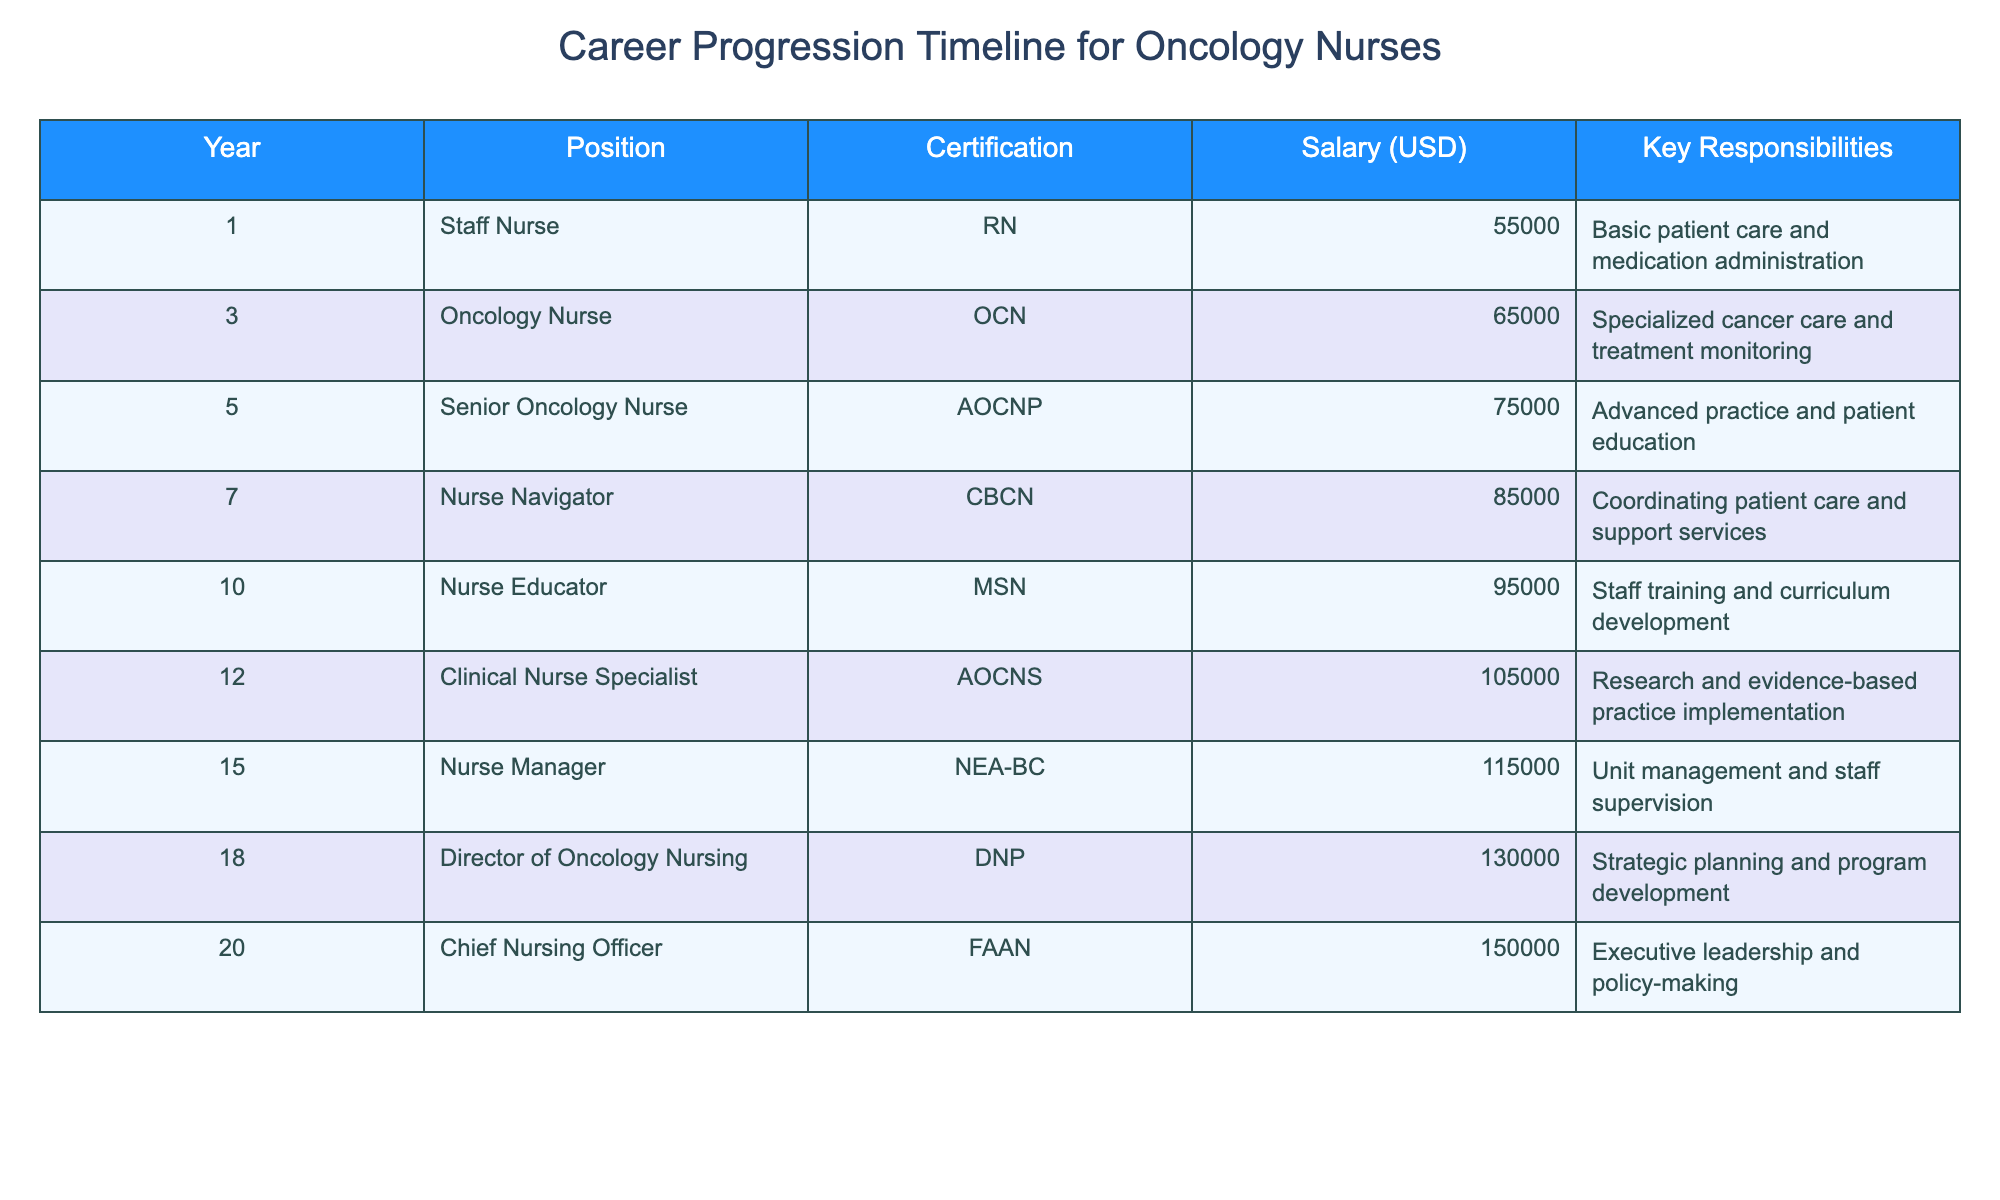What is the salary of a Nurse Navigator? The table lists the salary of a Nurse Navigator as 85,000 USD in year 7.
Answer: 85,000 USD How many years does it take to become a Chief Nursing Officer from a Staff Nurse? The table shows that it takes 20 years to progress from a Staff Nurse to a Chief Nursing Officer (Year 1 to Year 20).
Answer: 20 years What certification is required for a Nurse Educator? According to the table, the required certification for a Nurse Educator is MSN.
Answer: MSN What is the average salary of oncology nurses over the first 10 years? To find the average, add the salaries from years 1 to 10: 55,000 + 65,000 + 75,000 + 85,000 + 95,000 + 105,000 + 115,000 + 130,000 = 725,000, then divide by 8, which gives an average of 90,625 USD.
Answer: 90,625 USD Is the salary of a Clinical Nurse Specialist greater than that of a Nurse Navigator? The table shows that the salary of a Clinical Nurse Specialist is 105,000 USD and that of a Nurse Navigator is 85,000 USD, so yes, it is greater.
Answer: Yes What are the key responsibilities of a Senior Oncology Nurse? The table lists the responsibilities of a Senior Oncology Nurse as advanced practice and patient education.
Answer: Advanced practice and patient education How many positions are considered management roles in the table? The positions that can be classified as management roles are Nurse Manager, Director of Oncology Nursing, and Chief Nursing Officer, making a total of 3 management roles.
Answer: 3 positions What is the difference in salary between a Nurse Educator and a Nurse Manager? The salary of a Nurse Educator is 95,000 USD, and the salary of a Nurse Manager is 115,000 USD. The difference is 115,000 - 95,000 = 20,000 USD.
Answer: 20,000 USD In how many years does the salary exceed 100,000 USD? From years 12 to 20, the salaries are 105,000, 115,000, 130,000, and 150,000 USD, which counts as 8 years in total.
Answer: 8 years Which position has the highest salary, and what is it? The highest salary is for the Chief Nursing Officer at 150,000 USD.
Answer: Chief Nursing Officer, 150,000 USD 